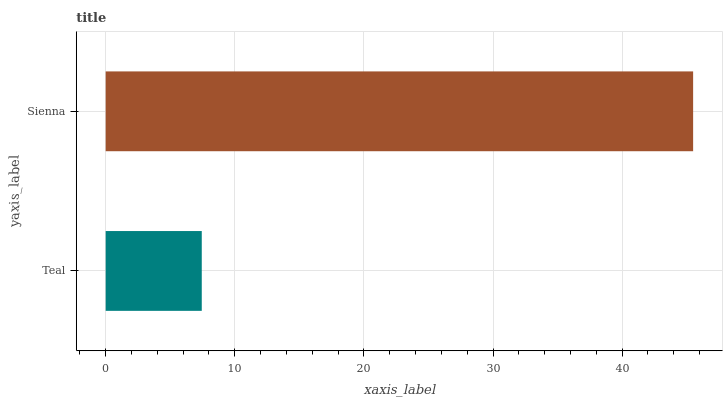Is Teal the minimum?
Answer yes or no. Yes. Is Sienna the maximum?
Answer yes or no. Yes. Is Sienna the minimum?
Answer yes or no. No. Is Sienna greater than Teal?
Answer yes or no. Yes. Is Teal less than Sienna?
Answer yes or no. Yes. Is Teal greater than Sienna?
Answer yes or no. No. Is Sienna less than Teal?
Answer yes or no. No. Is Sienna the high median?
Answer yes or no. Yes. Is Teal the low median?
Answer yes or no. Yes. Is Teal the high median?
Answer yes or no. No. Is Sienna the low median?
Answer yes or no. No. 